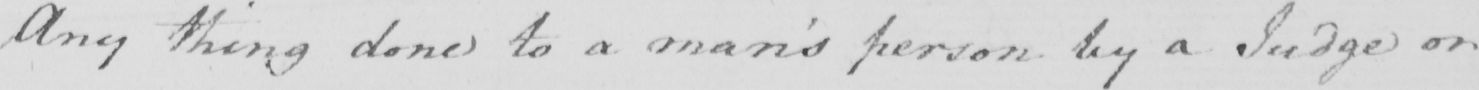Transcribe the text shown in this historical manuscript line. Any thing done to a man ' s person by a Judge or 